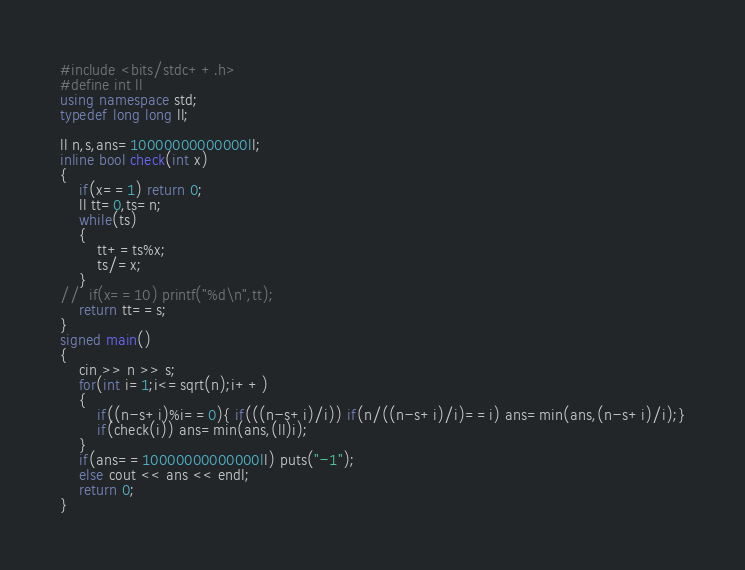Convert code to text. <code><loc_0><loc_0><loc_500><loc_500><_C++_>#include <bits/stdc++.h>
#define int ll
using namespace std;
typedef long long ll;

ll n,s,ans=10000000000000ll;
inline bool check(int x)
{
	if(x==1) return 0;
	ll tt=0,ts=n;
	while(ts)
	{
		tt+=ts%x;
		ts/=x;
	}
//	if(x==10) printf("%d\n",tt);
	return tt==s;
}
signed main()
{
	cin >> n >> s;
	for(int i=1;i<=sqrt(n);i++)
	{
		if((n-s+i)%i==0){ if(((n-s+i)/i)) if(n/((n-s+i)/i)==i) ans=min(ans,(n-s+i)/i);}
		if(check(i)) ans=min(ans,(ll)i);	
	}
	if(ans==10000000000000ll) puts("-1");
	else cout << ans << endl;
	return 0;
}
</code> 